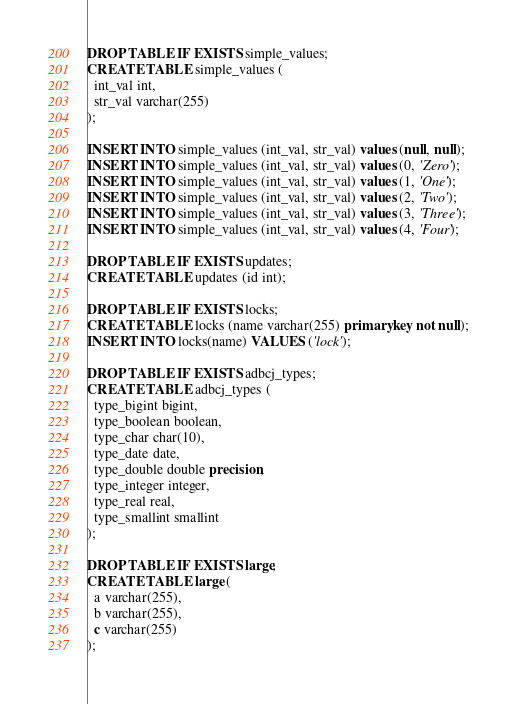Convert code to text. <code><loc_0><loc_0><loc_500><loc_500><_SQL_>DROP TABLE IF EXISTS simple_values;
CREATE TABLE simple_values (
  int_val int,
  str_val varchar(255)
);

INSERT INTO simple_values (int_val, str_val) values (null, null);
INSERT INTO simple_values (int_val, str_val) values (0, 'Zero');
INSERT INTO simple_values (int_val, str_val) values (1, 'One');
INSERT INTO simple_values (int_val, str_val) values (2, 'Two');
INSERT INTO simple_values (int_val, str_val) values (3, 'Three');
INSERT INTO simple_values (int_val, str_val) values (4, 'Four');

DROP TABLE IF EXISTS updates;
CREATE TABLE updates (id int);

DROP TABLE IF EXISTS locks;
CREATE TABLE locks (name varchar(255) primary key not null);
INSERT INTO locks(name) VALUES ('lock');

DROP TABLE IF EXISTS adbcj_types;
CREATE TABLE adbcj_types (
  type_bigint bigint,
  type_boolean boolean,
  type_char char(10),
  type_date date,
  type_double double precision,
  type_integer integer,
  type_real real,
  type_smallint smallint
);

DROP TABLE IF EXISTS large;
CREATE TABLE large (
  a varchar(255),
  b varchar(255),
  c varchar(255)
);</code> 